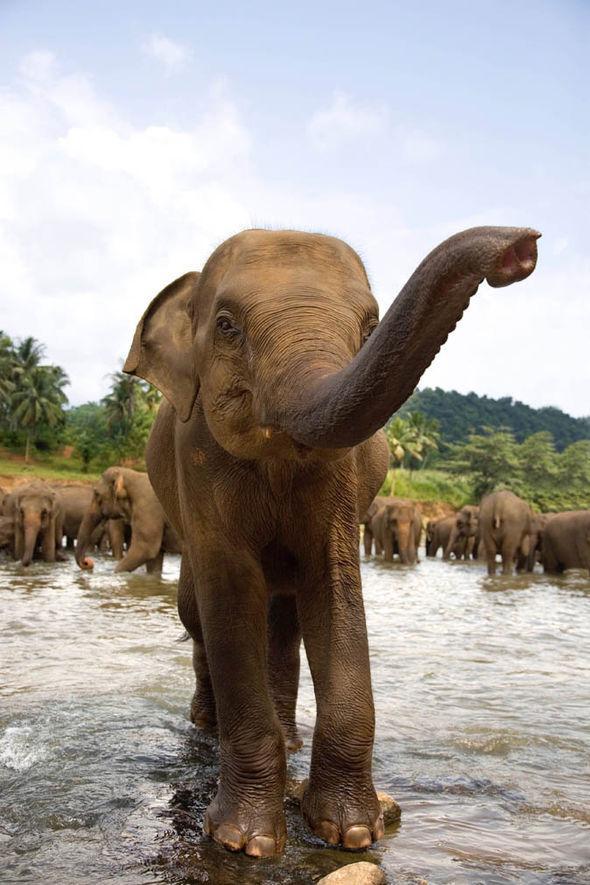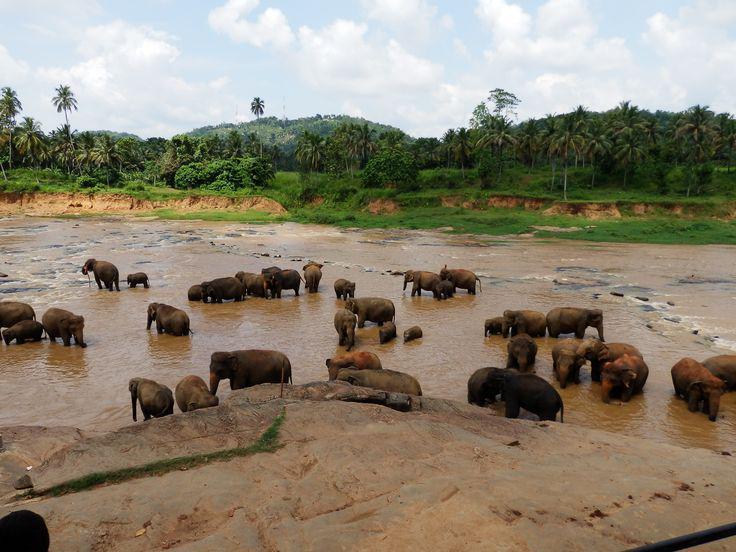The first image is the image on the left, the second image is the image on the right. For the images shown, is this caption "At least one elephant is in the foreground of an image standing in water." true? Answer yes or no. Yes. The first image is the image on the left, the second image is the image on the right. For the images shown, is this caption "At least one elephant is standing in water." true? Answer yes or no. Yes. 